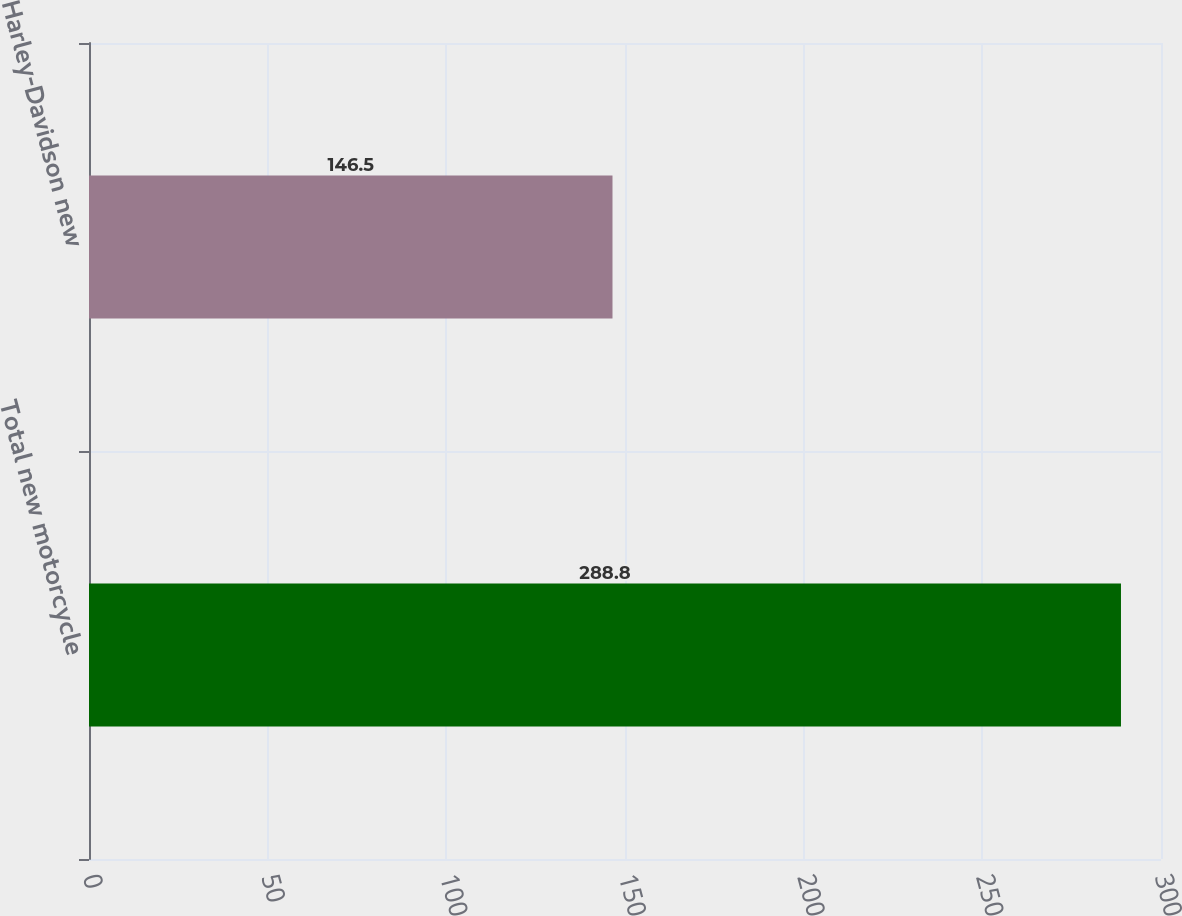Convert chart to OTSL. <chart><loc_0><loc_0><loc_500><loc_500><bar_chart><fcel>Total new motorcycle<fcel>Harley-Davidson new<nl><fcel>288.8<fcel>146.5<nl></chart> 